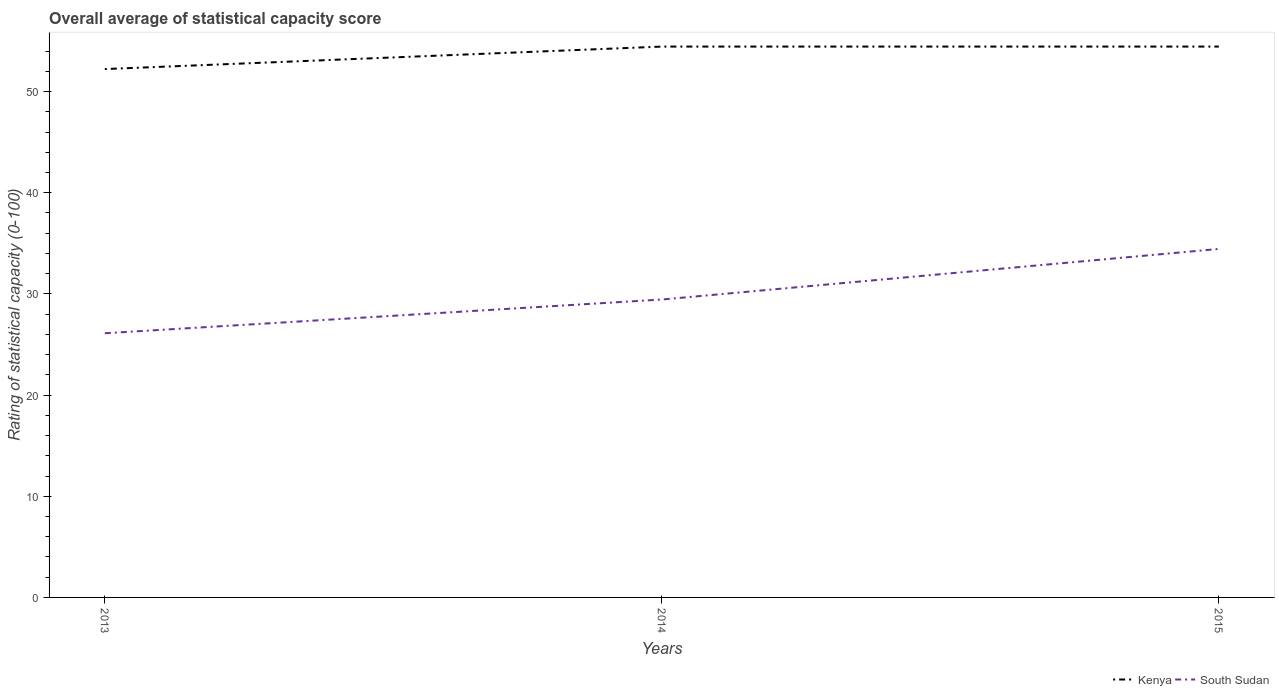Does the line corresponding to Kenya intersect with the line corresponding to South Sudan?
Your answer should be very brief. No. Is the number of lines equal to the number of legend labels?
Provide a succinct answer. Yes. Across all years, what is the maximum rating of statistical capacity in Kenya?
Give a very brief answer. 52.22. What is the total rating of statistical capacity in Kenya in the graph?
Give a very brief answer. -2.22. What is the difference between the highest and the second highest rating of statistical capacity in Kenya?
Give a very brief answer. 2.22. How many years are there in the graph?
Provide a succinct answer. 3. What is the difference between two consecutive major ticks on the Y-axis?
Provide a short and direct response. 10. Are the values on the major ticks of Y-axis written in scientific E-notation?
Offer a terse response. No. Does the graph contain grids?
Your answer should be very brief. No. How many legend labels are there?
Ensure brevity in your answer.  2. How are the legend labels stacked?
Ensure brevity in your answer.  Horizontal. What is the title of the graph?
Your response must be concise. Overall average of statistical capacity score. Does "Andorra" appear as one of the legend labels in the graph?
Give a very brief answer. No. What is the label or title of the X-axis?
Your response must be concise. Years. What is the label or title of the Y-axis?
Offer a terse response. Rating of statistical capacity (0-100). What is the Rating of statistical capacity (0-100) in Kenya in 2013?
Your answer should be compact. 52.22. What is the Rating of statistical capacity (0-100) of South Sudan in 2013?
Ensure brevity in your answer.  26.11. What is the Rating of statistical capacity (0-100) in Kenya in 2014?
Make the answer very short. 54.44. What is the Rating of statistical capacity (0-100) of South Sudan in 2014?
Offer a very short reply. 29.44. What is the Rating of statistical capacity (0-100) in Kenya in 2015?
Offer a terse response. 54.44. What is the Rating of statistical capacity (0-100) in South Sudan in 2015?
Offer a terse response. 34.44. Across all years, what is the maximum Rating of statistical capacity (0-100) in Kenya?
Your answer should be compact. 54.44. Across all years, what is the maximum Rating of statistical capacity (0-100) of South Sudan?
Provide a short and direct response. 34.44. Across all years, what is the minimum Rating of statistical capacity (0-100) of Kenya?
Make the answer very short. 52.22. Across all years, what is the minimum Rating of statistical capacity (0-100) in South Sudan?
Offer a terse response. 26.11. What is the total Rating of statistical capacity (0-100) of Kenya in the graph?
Provide a short and direct response. 161.11. What is the difference between the Rating of statistical capacity (0-100) in Kenya in 2013 and that in 2014?
Give a very brief answer. -2.22. What is the difference between the Rating of statistical capacity (0-100) of Kenya in 2013 and that in 2015?
Your answer should be compact. -2.22. What is the difference between the Rating of statistical capacity (0-100) in South Sudan in 2013 and that in 2015?
Offer a very short reply. -8.33. What is the difference between the Rating of statistical capacity (0-100) of Kenya in 2013 and the Rating of statistical capacity (0-100) of South Sudan in 2014?
Your answer should be compact. 22.78. What is the difference between the Rating of statistical capacity (0-100) in Kenya in 2013 and the Rating of statistical capacity (0-100) in South Sudan in 2015?
Provide a short and direct response. 17.78. What is the average Rating of statistical capacity (0-100) in Kenya per year?
Give a very brief answer. 53.7. What is the average Rating of statistical capacity (0-100) in South Sudan per year?
Make the answer very short. 30. In the year 2013, what is the difference between the Rating of statistical capacity (0-100) in Kenya and Rating of statistical capacity (0-100) in South Sudan?
Provide a succinct answer. 26.11. In the year 2015, what is the difference between the Rating of statistical capacity (0-100) of Kenya and Rating of statistical capacity (0-100) of South Sudan?
Offer a very short reply. 20. What is the ratio of the Rating of statistical capacity (0-100) of Kenya in 2013 to that in 2014?
Ensure brevity in your answer.  0.96. What is the ratio of the Rating of statistical capacity (0-100) in South Sudan in 2013 to that in 2014?
Offer a terse response. 0.89. What is the ratio of the Rating of statistical capacity (0-100) of Kenya in 2013 to that in 2015?
Provide a short and direct response. 0.96. What is the ratio of the Rating of statistical capacity (0-100) in South Sudan in 2013 to that in 2015?
Ensure brevity in your answer.  0.76. What is the ratio of the Rating of statistical capacity (0-100) of South Sudan in 2014 to that in 2015?
Keep it short and to the point. 0.85. What is the difference between the highest and the lowest Rating of statistical capacity (0-100) in Kenya?
Ensure brevity in your answer.  2.22. What is the difference between the highest and the lowest Rating of statistical capacity (0-100) in South Sudan?
Your answer should be compact. 8.33. 